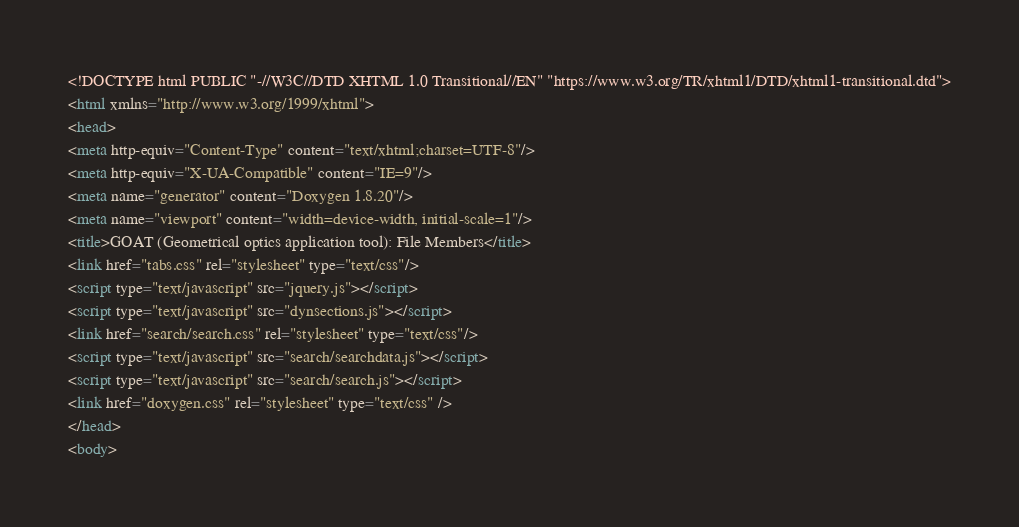Convert code to text. <code><loc_0><loc_0><loc_500><loc_500><_HTML_><!DOCTYPE html PUBLIC "-//W3C//DTD XHTML 1.0 Transitional//EN" "https://www.w3.org/TR/xhtml1/DTD/xhtml1-transitional.dtd">
<html xmlns="http://www.w3.org/1999/xhtml">
<head>
<meta http-equiv="Content-Type" content="text/xhtml;charset=UTF-8"/>
<meta http-equiv="X-UA-Compatible" content="IE=9"/>
<meta name="generator" content="Doxygen 1.8.20"/>
<meta name="viewport" content="width=device-width, initial-scale=1"/>
<title>GOAT (Geometrical optics application tool): File Members</title>
<link href="tabs.css" rel="stylesheet" type="text/css"/>
<script type="text/javascript" src="jquery.js"></script>
<script type="text/javascript" src="dynsections.js"></script>
<link href="search/search.css" rel="stylesheet" type="text/css"/>
<script type="text/javascript" src="search/searchdata.js"></script>
<script type="text/javascript" src="search/search.js"></script>
<link href="doxygen.css" rel="stylesheet" type="text/css" />
</head>
<body></code> 